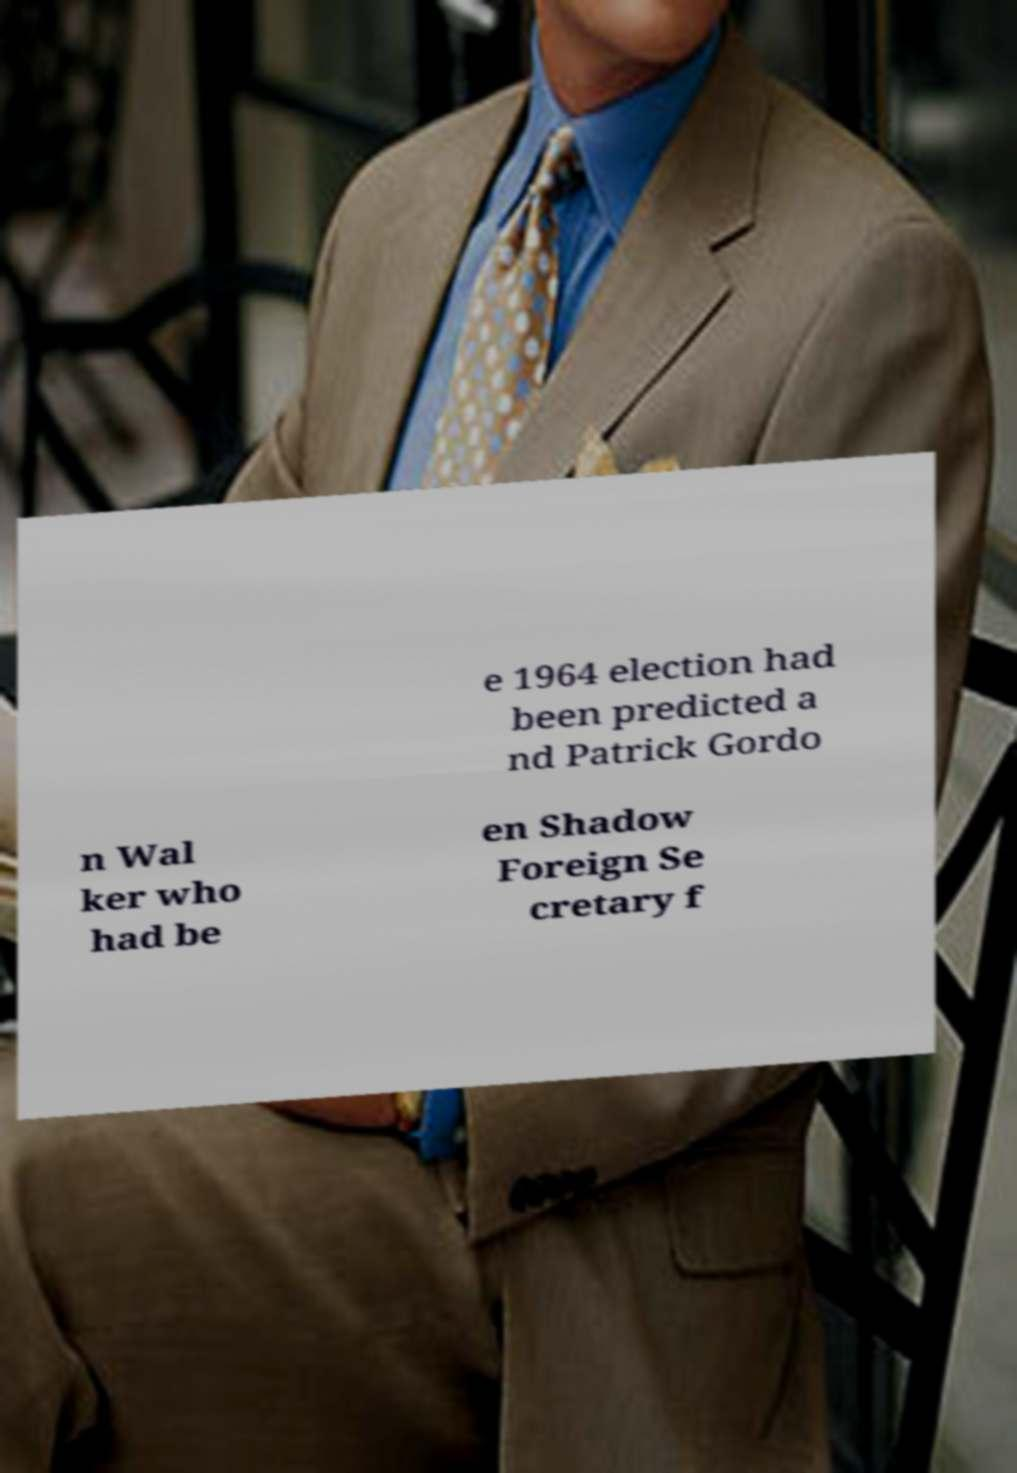Please read and relay the text visible in this image. What does it say? e 1964 election had been predicted a nd Patrick Gordo n Wal ker who had be en Shadow Foreign Se cretary f 